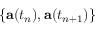<formula> <loc_0><loc_0><loc_500><loc_500>\{ a ( t _ { n } ) , a ( t _ { n + 1 } ) \}</formula> 